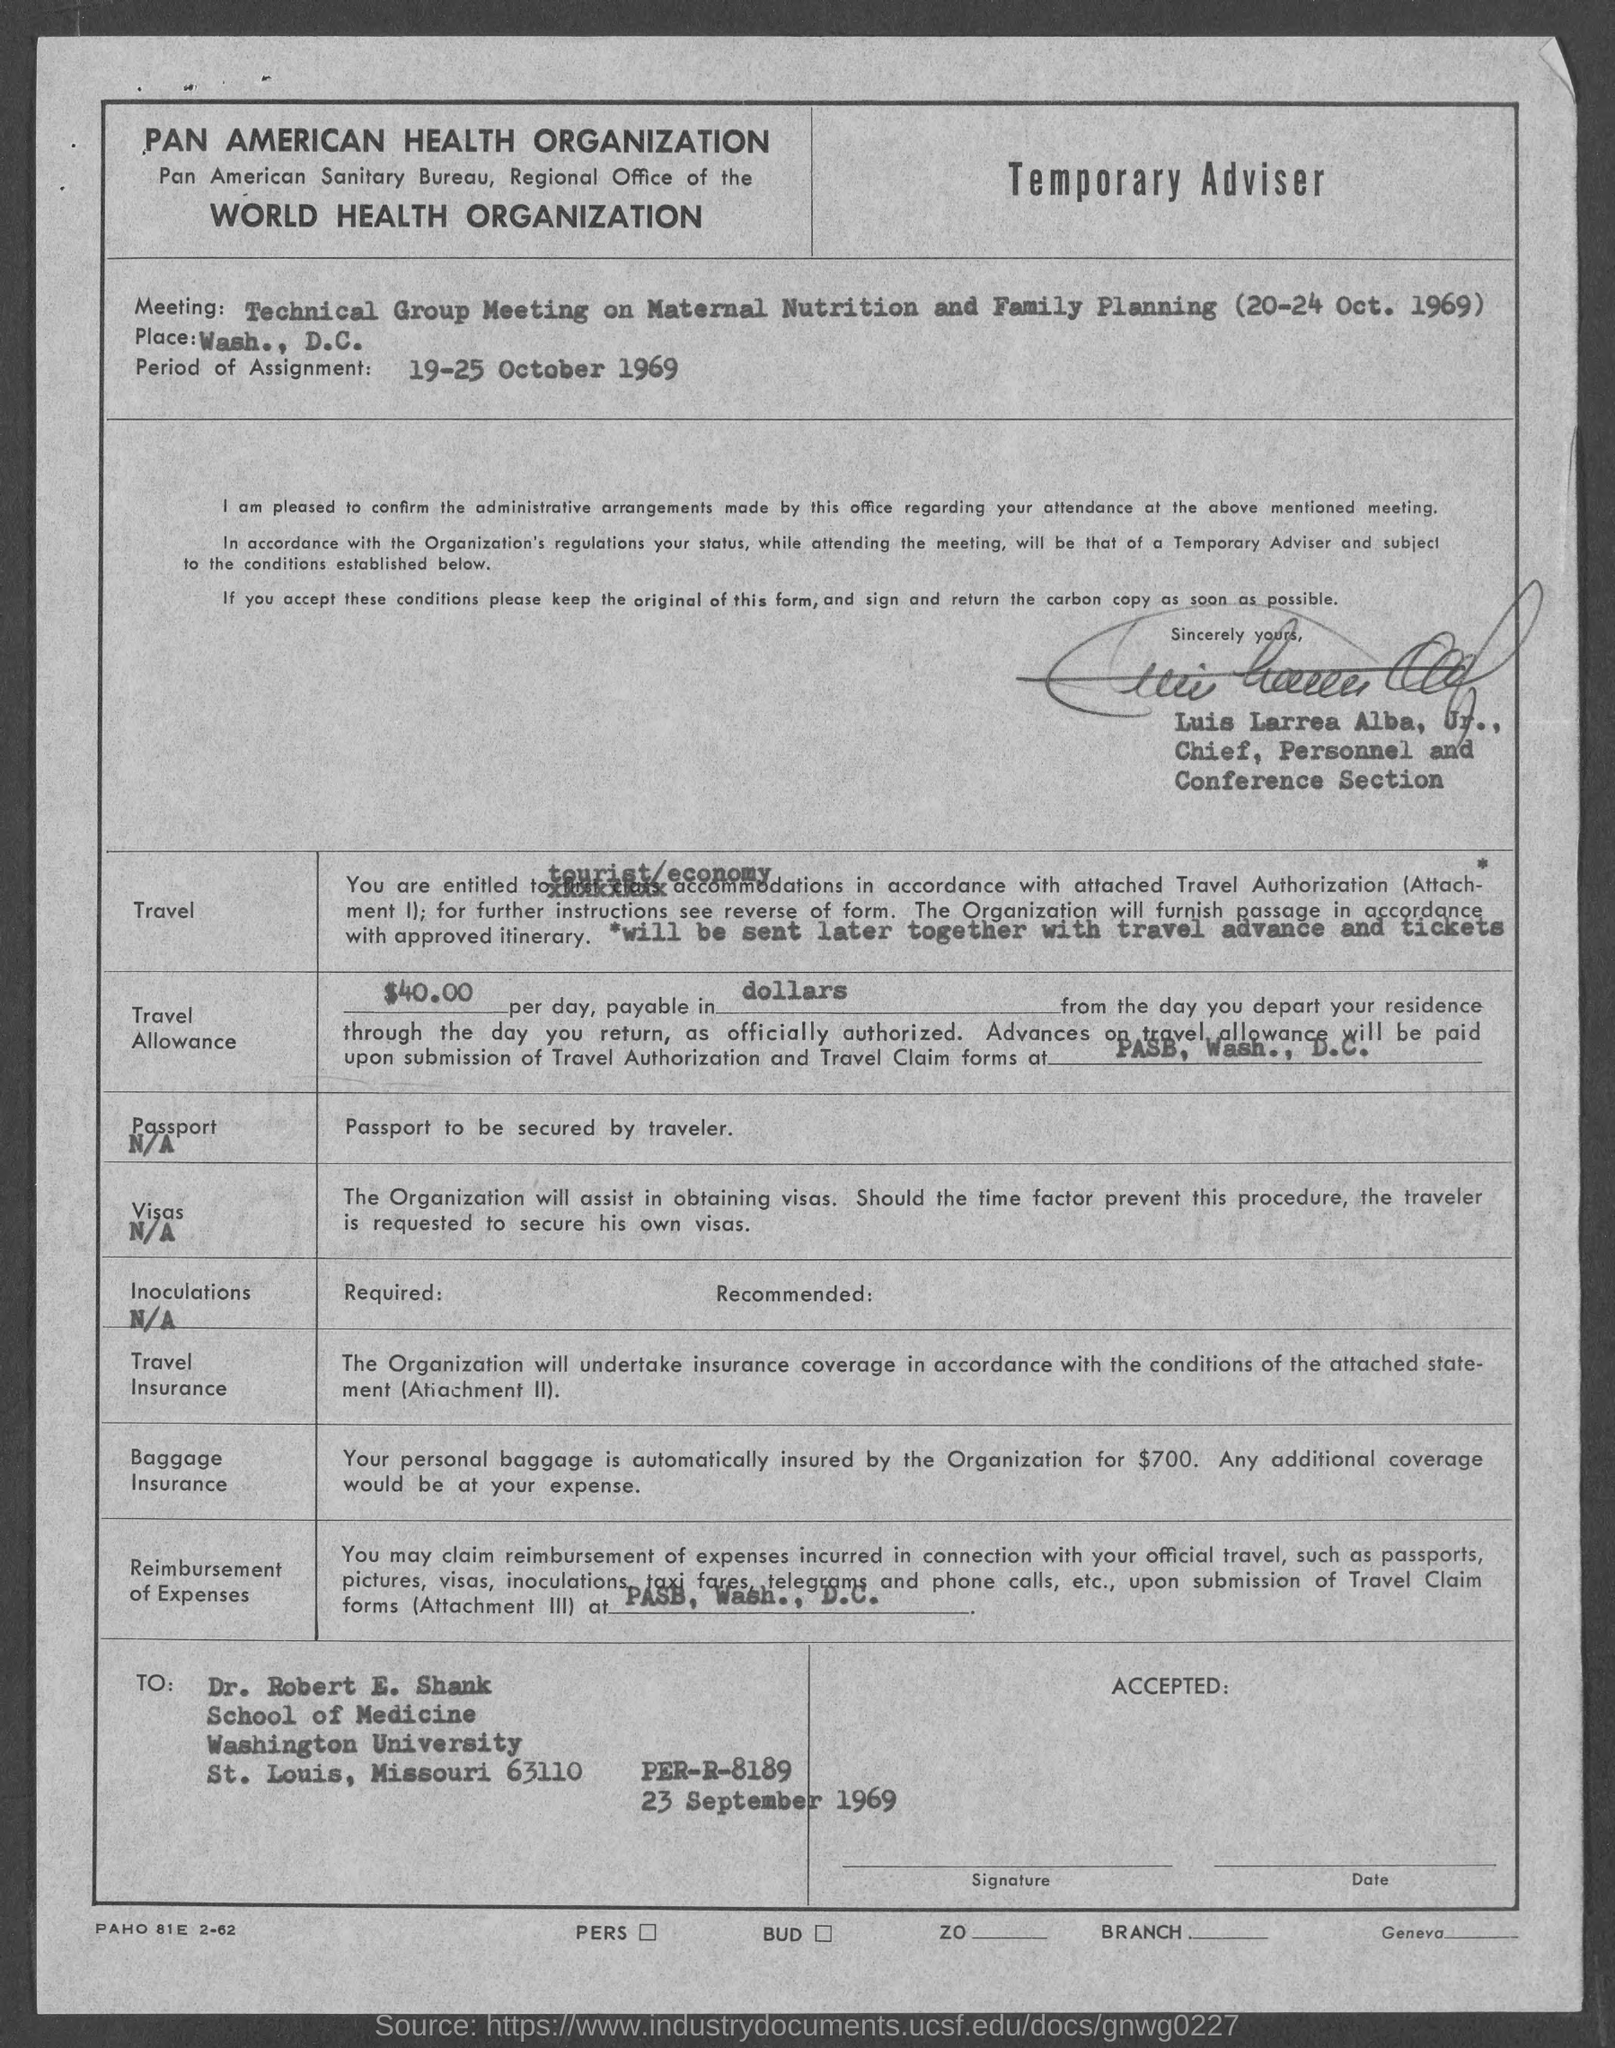Specify some key components in this picture. The meeting is to discuss maternal nutrition and family planning in a technical context. The period of the assignment was from 19 to 25 October 1969. The Travel Allowance is $40.00 per day, payable in dollars. The form has been signed by Luis Larrea Alba, Jr. The meeting is scheduled to take place on 20-24 October 1969. 